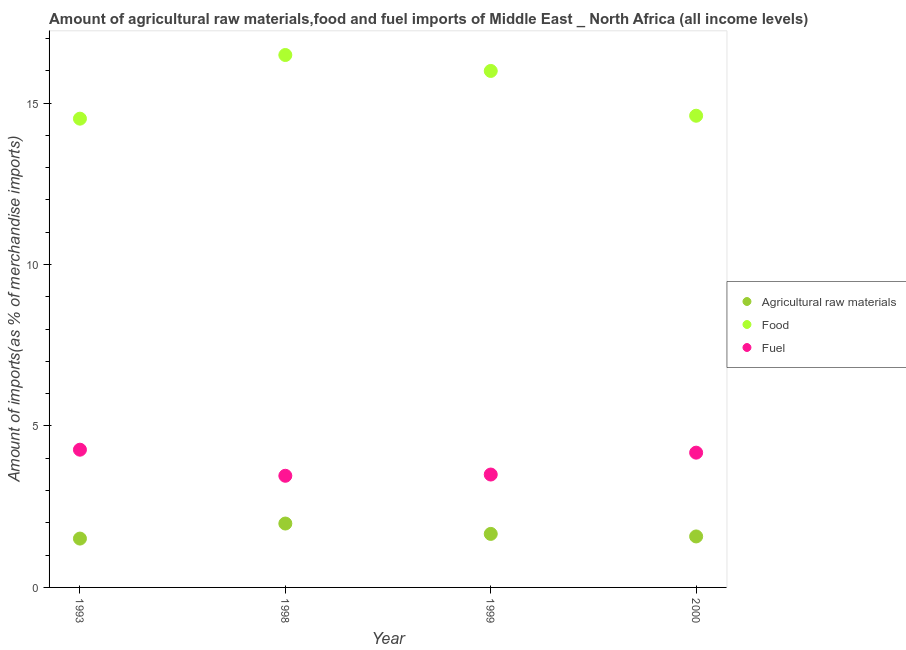How many different coloured dotlines are there?
Ensure brevity in your answer.  3. Is the number of dotlines equal to the number of legend labels?
Offer a very short reply. Yes. What is the percentage of food imports in 1998?
Your response must be concise. 16.49. Across all years, what is the maximum percentage of raw materials imports?
Give a very brief answer. 1.98. Across all years, what is the minimum percentage of raw materials imports?
Offer a terse response. 1.51. What is the total percentage of fuel imports in the graph?
Your response must be concise. 15.39. What is the difference between the percentage of food imports in 1999 and that in 2000?
Make the answer very short. 1.39. What is the difference between the percentage of food imports in 1993 and the percentage of fuel imports in 2000?
Make the answer very short. 10.34. What is the average percentage of fuel imports per year?
Give a very brief answer. 3.85. In the year 2000, what is the difference between the percentage of raw materials imports and percentage of food imports?
Give a very brief answer. -13.03. In how many years, is the percentage of raw materials imports greater than 15 %?
Provide a short and direct response. 0. What is the ratio of the percentage of fuel imports in 1999 to that in 2000?
Keep it short and to the point. 0.84. Is the difference between the percentage of fuel imports in 1993 and 1999 greater than the difference between the percentage of food imports in 1993 and 1999?
Ensure brevity in your answer.  Yes. What is the difference between the highest and the second highest percentage of raw materials imports?
Keep it short and to the point. 0.32. What is the difference between the highest and the lowest percentage of raw materials imports?
Your answer should be compact. 0.47. Does the percentage of fuel imports monotonically increase over the years?
Offer a very short reply. No. Is the percentage of fuel imports strictly less than the percentage of food imports over the years?
Keep it short and to the point. Yes. How many dotlines are there?
Your answer should be very brief. 3. How many years are there in the graph?
Your answer should be very brief. 4. What is the difference between two consecutive major ticks on the Y-axis?
Your response must be concise. 5. Are the values on the major ticks of Y-axis written in scientific E-notation?
Your answer should be compact. No. Does the graph contain grids?
Your answer should be very brief. No. How many legend labels are there?
Provide a short and direct response. 3. How are the legend labels stacked?
Make the answer very short. Vertical. What is the title of the graph?
Your response must be concise. Amount of agricultural raw materials,food and fuel imports of Middle East _ North Africa (all income levels). Does "Infant(female)" appear as one of the legend labels in the graph?
Ensure brevity in your answer.  No. What is the label or title of the X-axis?
Offer a terse response. Year. What is the label or title of the Y-axis?
Offer a very short reply. Amount of imports(as % of merchandise imports). What is the Amount of imports(as % of merchandise imports) of Agricultural raw materials in 1993?
Make the answer very short. 1.51. What is the Amount of imports(as % of merchandise imports) in Food in 1993?
Your answer should be very brief. 14.52. What is the Amount of imports(as % of merchandise imports) in Fuel in 1993?
Your answer should be compact. 4.27. What is the Amount of imports(as % of merchandise imports) of Agricultural raw materials in 1998?
Provide a short and direct response. 1.98. What is the Amount of imports(as % of merchandise imports) in Food in 1998?
Provide a succinct answer. 16.49. What is the Amount of imports(as % of merchandise imports) in Fuel in 1998?
Make the answer very short. 3.46. What is the Amount of imports(as % of merchandise imports) of Agricultural raw materials in 1999?
Offer a terse response. 1.66. What is the Amount of imports(as % of merchandise imports) of Food in 1999?
Ensure brevity in your answer.  16. What is the Amount of imports(as % of merchandise imports) of Fuel in 1999?
Offer a very short reply. 3.5. What is the Amount of imports(as % of merchandise imports) of Agricultural raw materials in 2000?
Your answer should be compact. 1.58. What is the Amount of imports(as % of merchandise imports) of Food in 2000?
Your answer should be very brief. 14.61. What is the Amount of imports(as % of merchandise imports) of Fuel in 2000?
Keep it short and to the point. 4.17. Across all years, what is the maximum Amount of imports(as % of merchandise imports) of Agricultural raw materials?
Your response must be concise. 1.98. Across all years, what is the maximum Amount of imports(as % of merchandise imports) of Food?
Keep it short and to the point. 16.49. Across all years, what is the maximum Amount of imports(as % of merchandise imports) of Fuel?
Give a very brief answer. 4.27. Across all years, what is the minimum Amount of imports(as % of merchandise imports) in Agricultural raw materials?
Keep it short and to the point. 1.51. Across all years, what is the minimum Amount of imports(as % of merchandise imports) of Food?
Offer a very short reply. 14.52. Across all years, what is the minimum Amount of imports(as % of merchandise imports) in Fuel?
Your answer should be very brief. 3.46. What is the total Amount of imports(as % of merchandise imports) in Agricultural raw materials in the graph?
Your response must be concise. 6.73. What is the total Amount of imports(as % of merchandise imports) in Food in the graph?
Ensure brevity in your answer.  61.62. What is the total Amount of imports(as % of merchandise imports) in Fuel in the graph?
Offer a very short reply. 15.39. What is the difference between the Amount of imports(as % of merchandise imports) in Agricultural raw materials in 1993 and that in 1998?
Give a very brief answer. -0.47. What is the difference between the Amount of imports(as % of merchandise imports) in Food in 1993 and that in 1998?
Ensure brevity in your answer.  -1.97. What is the difference between the Amount of imports(as % of merchandise imports) in Fuel in 1993 and that in 1998?
Your answer should be very brief. 0.81. What is the difference between the Amount of imports(as % of merchandise imports) in Agricultural raw materials in 1993 and that in 1999?
Make the answer very short. -0.14. What is the difference between the Amount of imports(as % of merchandise imports) of Food in 1993 and that in 1999?
Keep it short and to the point. -1.48. What is the difference between the Amount of imports(as % of merchandise imports) in Fuel in 1993 and that in 1999?
Make the answer very short. 0.77. What is the difference between the Amount of imports(as % of merchandise imports) in Agricultural raw materials in 1993 and that in 2000?
Your answer should be compact. -0.07. What is the difference between the Amount of imports(as % of merchandise imports) in Food in 1993 and that in 2000?
Provide a short and direct response. -0.09. What is the difference between the Amount of imports(as % of merchandise imports) in Fuel in 1993 and that in 2000?
Offer a terse response. 0.09. What is the difference between the Amount of imports(as % of merchandise imports) of Agricultural raw materials in 1998 and that in 1999?
Offer a terse response. 0.32. What is the difference between the Amount of imports(as % of merchandise imports) of Food in 1998 and that in 1999?
Offer a very short reply. 0.49. What is the difference between the Amount of imports(as % of merchandise imports) of Fuel in 1998 and that in 1999?
Provide a succinct answer. -0.04. What is the difference between the Amount of imports(as % of merchandise imports) of Agricultural raw materials in 1998 and that in 2000?
Provide a succinct answer. 0.4. What is the difference between the Amount of imports(as % of merchandise imports) of Food in 1998 and that in 2000?
Provide a short and direct response. 1.88. What is the difference between the Amount of imports(as % of merchandise imports) in Fuel in 1998 and that in 2000?
Ensure brevity in your answer.  -0.72. What is the difference between the Amount of imports(as % of merchandise imports) of Agricultural raw materials in 1999 and that in 2000?
Offer a terse response. 0.08. What is the difference between the Amount of imports(as % of merchandise imports) in Food in 1999 and that in 2000?
Ensure brevity in your answer.  1.39. What is the difference between the Amount of imports(as % of merchandise imports) in Fuel in 1999 and that in 2000?
Offer a terse response. -0.68. What is the difference between the Amount of imports(as % of merchandise imports) in Agricultural raw materials in 1993 and the Amount of imports(as % of merchandise imports) in Food in 1998?
Offer a terse response. -14.98. What is the difference between the Amount of imports(as % of merchandise imports) of Agricultural raw materials in 1993 and the Amount of imports(as % of merchandise imports) of Fuel in 1998?
Your answer should be compact. -1.95. What is the difference between the Amount of imports(as % of merchandise imports) of Food in 1993 and the Amount of imports(as % of merchandise imports) of Fuel in 1998?
Provide a succinct answer. 11.06. What is the difference between the Amount of imports(as % of merchandise imports) in Agricultural raw materials in 1993 and the Amount of imports(as % of merchandise imports) in Food in 1999?
Your response must be concise. -14.48. What is the difference between the Amount of imports(as % of merchandise imports) in Agricultural raw materials in 1993 and the Amount of imports(as % of merchandise imports) in Fuel in 1999?
Give a very brief answer. -1.98. What is the difference between the Amount of imports(as % of merchandise imports) in Food in 1993 and the Amount of imports(as % of merchandise imports) in Fuel in 1999?
Offer a very short reply. 11.02. What is the difference between the Amount of imports(as % of merchandise imports) of Agricultural raw materials in 1993 and the Amount of imports(as % of merchandise imports) of Food in 2000?
Provide a short and direct response. -13.1. What is the difference between the Amount of imports(as % of merchandise imports) in Agricultural raw materials in 1993 and the Amount of imports(as % of merchandise imports) in Fuel in 2000?
Keep it short and to the point. -2.66. What is the difference between the Amount of imports(as % of merchandise imports) of Food in 1993 and the Amount of imports(as % of merchandise imports) of Fuel in 2000?
Ensure brevity in your answer.  10.34. What is the difference between the Amount of imports(as % of merchandise imports) of Agricultural raw materials in 1998 and the Amount of imports(as % of merchandise imports) of Food in 1999?
Ensure brevity in your answer.  -14.02. What is the difference between the Amount of imports(as % of merchandise imports) of Agricultural raw materials in 1998 and the Amount of imports(as % of merchandise imports) of Fuel in 1999?
Your response must be concise. -1.52. What is the difference between the Amount of imports(as % of merchandise imports) in Food in 1998 and the Amount of imports(as % of merchandise imports) in Fuel in 1999?
Offer a very short reply. 12.99. What is the difference between the Amount of imports(as % of merchandise imports) of Agricultural raw materials in 1998 and the Amount of imports(as % of merchandise imports) of Food in 2000?
Your answer should be very brief. -12.63. What is the difference between the Amount of imports(as % of merchandise imports) in Agricultural raw materials in 1998 and the Amount of imports(as % of merchandise imports) in Fuel in 2000?
Make the answer very short. -2.2. What is the difference between the Amount of imports(as % of merchandise imports) in Food in 1998 and the Amount of imports(as % of merchandise imports) in Fuel in 2000?
Offer a terse response. 12.32. What is the difference between the Amount of imports(as % of merchandise imports) in Agricultural raw materials in 1999 and the Amount of imports(as % of merchandise imports) in Food in 2000?
Offer a terse response. -12.95. What is the difference between the Amount of imports(as % of merchandise imports) of Agricultural raw materials in 1999 and the Amount of imports(as % of merchandise imports) of Fuel in 2000?
Ensure brevity in your answer.  -2.52. What is the difference between the Amount of imports(as % of merchandise imports) in Food in 1999 and the Amount of imports(as % of merchandise imports) in Fuel in 2000?
Ensure brevity in your answer.  11.82. What is the average Amount of imports(as % of merchandise imports) of Agricultural raw materials per year?
Your answer should be compact. 1.68. What is the average Amount of imports(as % of merchandise imports) of Food per year?
Provide a short and direct response. 15.4. What is the average Amount of imports(as % of merchandise imports) of Fuel per year?
Offer a terse response. 3.85. In the year 1993, what is the difference between the Amount of imports(as % of merchandise imports) of Agricultural raw materials and Amount of imports(as % of merchandise imports) of Food?
Provide a succinct answer. -13.01. In the year 1993, what is the difference between the Amount of imports(as % of merchandise imports) of Agricultural raw materials and Amount of imports(as % of merchandise imports) of Fuel?
Provide a short and direct response. -2.75. In the year 1993, what is the difference between the Amount of imports(as % of merchandise imports) of Food and Amount of imports(as % of merchandise imports) of Fuel?
Make the answer very short. 10.25. In the year 1998, what is the difference between the Amount of imports(as % of merchandise imports) of Agricultural raw materials and Amount of imports(as % of merchandise imports) of Food?
Your answer should be very brief. -14.51. In the year 1998, what is the difference between the Amount of imports(as % of merchandise imports) of Agricultural raw materials and Amount of imports(as % of merchandise imports) of Fuel?
Your response must be concise. -1.48. In the year 1998, what is the difference between the Amount of imports(as % of merchandise imports) of Food and Amount of imports(as % of merchandise imports) of Fuel?
Provide a succinct answer. 13.03. In the year 1999, what is the difference between the Amount of imports(as % of merchandise imports) of Agricultural raw materials and Amount of imports(as % of merchandise imports) of Food?
Provide a succinct answer. -14.34. In the year 1999, what is the difference between the Amount of imports(as % of merchandise imports) in Agricultural raw materials and Amount of imports(as % of merchandise imports) in Fuel?
Ensure brevity in your answer.  -1.84. In the year 1999, what is the difference between the Amount of imports(as % of merchandise imports) in Food and Amount of imports(as % of merchandise imports) in Fuel?
Offer a terse response. 12.5. In the year 2000, what is the difference between the Amount of imports(as % of merchandise imports) of Agricultural raw materials and Amount of imports(as % of merchandise imports) of Food?
Ensure brevity in your answer.  -13.03. In the year 2000, what is the difference between the Amount of imports(as % of merchandise imports) in Agricultural raw materials and Amount of imports(as % of merchandise imports) in Fuel?
Your answer should be compact. -2.6. In the year 2000, what is the difference between the Amount of imports(as % of merchandise imports) of Food and Amount of imports(as % of merchandise imports) of Fuel?
Your response must be concise. 10.44. What is the ratio of the Amount of imports(as % of merchandise imports) in Agricultural raw materials in 1993 to that in 1998?
Offer a terse response. 0.76. What is the ratio of the Amount of imports(as % of merchandise imports) of Food in 1993 to that in 1998?
Offer a terse response. 0.88. What is the ratio of the Amount of imports(as % of merchandise imports) in Fuel in 1993 to that in 1998?
Give a very brief answer. 1.23. What is the ratio of the Amount of imports(as % of merchandise imports) of Agricultural raw materials in 1993 to that in 1999?
Offer a very short reply. 0.91. What is the ratio of the Amount of imports(as % of merchandise imports) in Food in 1993 to that in 1999?
Give a very brief answer. 0.91. What is the ratio of the Amount of imports(as % of merchandise imports) of Fuel in 1993 to that in 1999?
Make the answer very short. 1.22. What is the ratio of the Amount of imports(as % of merchandise imports) in Agricultural raw materials in 1993 to that in 2000?
Your answer should be very brief. 0.96. What is the ratio of the Amount of imports(as % of merchandise imports) of Food in 1993 to that in 2000?
Provide a short and direct response. 0.99. What is the ratio of the Amount of imports(as % of merchandise imports) in Agricultural raw materials in 1998 to that in 1999?
Give a very brief answer. 1.19. What is the ratio of the Amount of imports(as % of merchandise imports) in Food in 1998 to that in 1999?
Offer a very short reply. 1.03. What is the ratio of the Amount of imports(as % of merchandise imports) of Fuel in 1998 to that in 1999?
Provide a succinct answer. 0.99. What is the ratio of the Amount of imports(as % of merchandise imports) of Agricultural raw materials in 1998 to that in 2000?
Provide a short and direct response. 1.25. What is the ratio of the Amount of imports(as % of merchandise imports) of Food in 1998 to that in 2000?
Provide a short and direct response. 1.13. What is the ratio of the Amount of imports(as % of merchandise imports) of Fuel in 1998 to that in 2000?
Your answer should be very brief. 0.83. What is the ratio of the Amount of imports(as % of merchandise imports) of Agricultural raw materials in 1999 to that in 2000?
Provide a short and direct response. 1.05. What is the ratio of the Amount of imports(as % of merchandise imports) in Food in 1999 to that in 2000?
Make the answer very short. 1.09. What is the ratio of the Amount of imports(as % of merchandise imports) of Fuel in 1999 to that in 2000?
Ensure brevity in your answer.  0.84. What is the difference between the highest and the second highest Amount of imports(as % of merchandise imports) in Agricultural raw materials?
Offer a terse response. 0.32. What is the difference between the highest and the second highest Amount of imports(as % of merchandise imports) of Food?
Provide a short and direct response. 0.49. What is the difference between the highest and the second highest Amount of imports(as % of merchandise imports) in Fuel?
Make the answer very short. 0.09. What is the difference between the highest and the lowest Amount of imports(as % of merchandise imports) of Agricultural raw materials?
Give a very brief answer. 0.47. What is the difference between the highest and the lowest Amount of imports(as % of merchandise imports) of Food?
Offer a terse response. 1.97. What is the difference between the highest and the lowest Amount of imports(as % of merchandise imports) of Fuel?
Offer a very short reply. 0.81. 